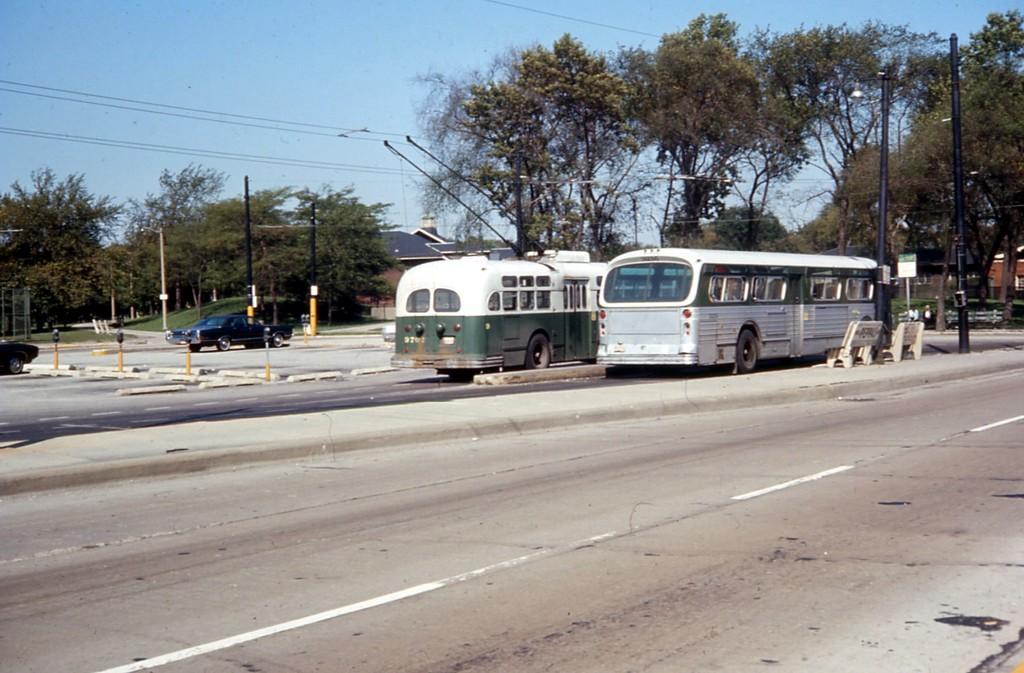What structures can be seen in the image? There are electric poles in the image. What else can be seen on the same plane as the electric poles? There are vehicles on the road in the image. What can be seen in the distance behind the electric poles and vehicles? There are trees, buildings, and the sky visible in the background of the image. How many times does the person in the image sneeze? There is no person present in the image, so it is impossible to determine how many times they sneeze. 